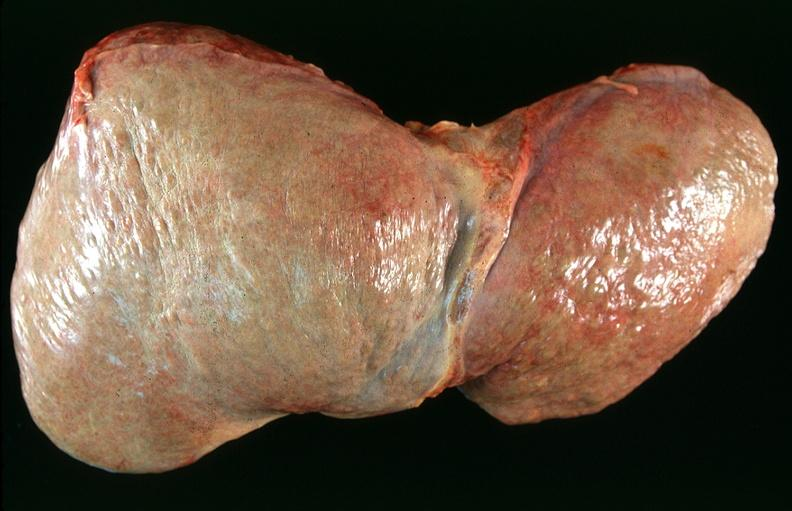what does this image show?
Answer the question using a single word or phrase. Liver 